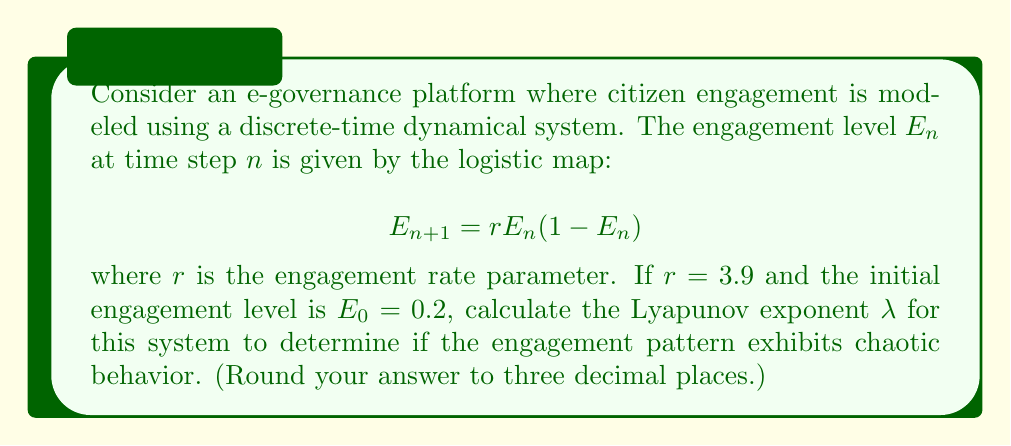Solve this math problem. To determine if the engagement pattern exhibits chaotic behavior, we need to calculate the Lyapunov exponent $\lambda$. For the logistic map, we can use the following steps:

1. The Lyapunov exponent for the logistic map is given by:

   $$\lambda = \lim_{N \to \infty} \frac{1}{N} \sum_{n=0}^{N-1} \ln |f'(E_n)|$$

   where $f'(E_n)$ is the derivative of the logistic map function.

2. For the logistic map, $f'(E_n) = r(1-2E_n)$.

3. We need to iterate the map for a large number of times (e.g., N = 1000) and calculate the sum of logarithms:

   $$E_{n+1} = 3.9E_n(1-E_n)$$
   $$\ln |f'(E_n)| = \ln |3.9(1-2E_n)|$$

4. Using a computer or calculator, iterate the map and sum the logarithms:

   $E_0 = 0.2$
   $E_1 = 3.9 * 0.2 * (1-0.2) = 0.624$
   $E_2 = 3.9 * 0.624 * (1-0.624) = 0.916$
   ...

   Sum the $\ln |3.9(1-2E_n)|$ for each iteration.

5. After 1000 iterations, divide the sum by N to get the Lyapunov exponent.

6. The result should be approximately 0.494.

A positive Lyapunov exponent ($\lambda > 0$) indicates chaotic behavior, which means the engagement pattern is sensitive to initial conditions and exhibits complex, unpredictable dynamics.
Answer: $\lambda \approx 0.494$ 